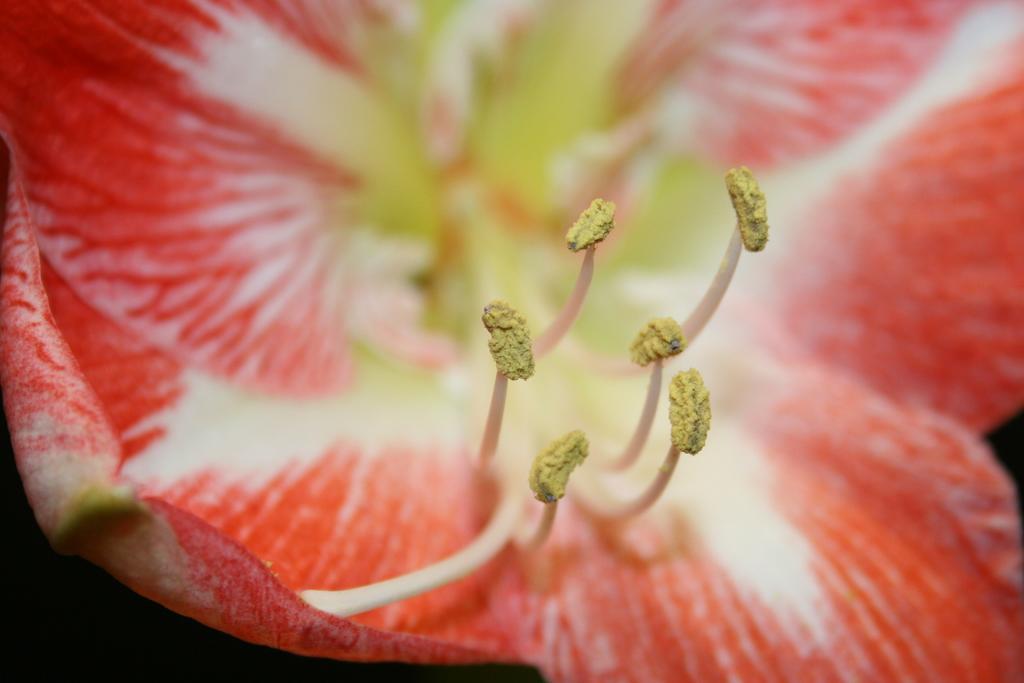In one or two sentences, can you explain what this image depicts? In this picture we can observe a flower which is in red color. There are some buds which were in yellow color. 